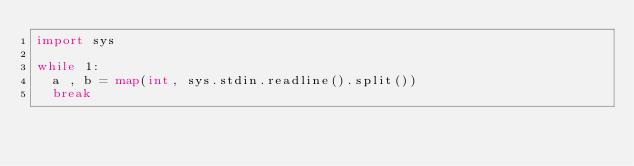Convert code to text. <code><loc_0><loc_0><loc_500><loc_500><_Python_>import sys

while 1:
  a , b = map(int, sys.stdin.readline().split())
  break</code> 